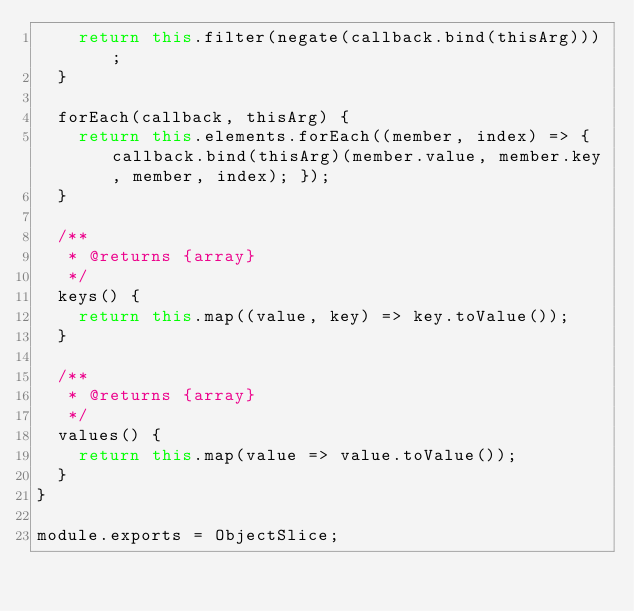Convert code to text. <code><loc_0><loc_0><loc_500><loc_500><_JavaScript_>    return this.filter(negate(callback.bind(thisArg)));
  }

  forEach(callback, thisArg) {
    return this.elements.forEach((member, index) => { callback.bind(thisArg)(member.value, member.key, member, index); });
  }

  /**
   * @returns {array}
   */
  keys() {
    return this.map((value, key) => key.toValue());
  }

  /**
   * @returns {array}
   */
  values() {
    return this.map(value => value.toValue());
  }
}

module.exports = ObjectSlice;
</code> 